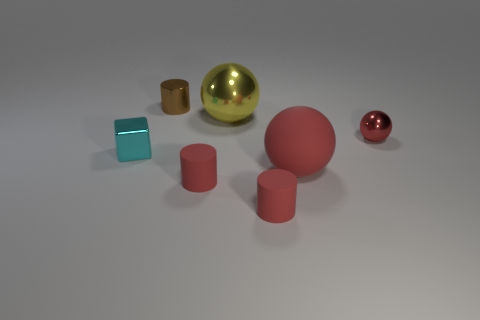Can you describe the arrangement of objects in this image? Sure, the image presents a collection of geometric shapes arranged on a flat surface. At the front, there is a medium-sized gold sphere beside a smaller red sphere and a small cyan metal cube. Behind these are two identical pink cylinders, positioned vertically, and a large red sphere to the left.  Are there any patterns or themes noticeable here? The image seems to have an underlying theme of geometric simplicity and contrast. The shapes are plain, with a variety of colors that create contrast—metallic hues against matte pink and a touch of red and cyan. The arrangement seems random, but the contrast in sizes and colors might suggest a study in scale and hue. 